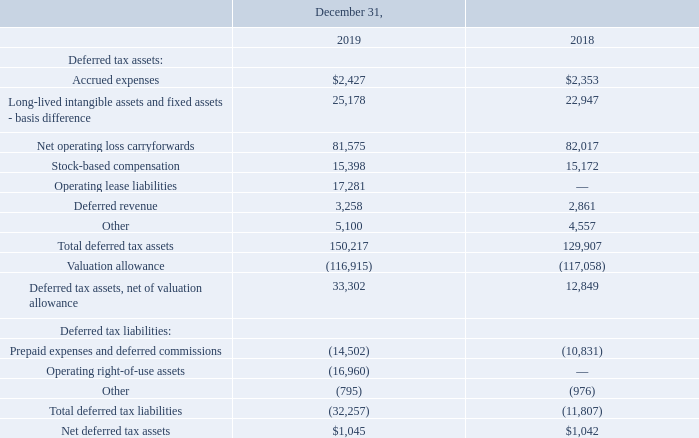Major components of the Company’s deferred tax assets (liabilities) are as follows (in thousands):
At December 31, 2019, the Company had federal, state, and foreign net operating losses of approximately $256.8 million, $275.5 million, and $89.7 million, respectively. The federal net operating loss carryforward will begin expiring in 2022, the state net operating loss carryforward will begin expiring in 2020, and the foreign net operating loss has an unlimited carryforward period. The Internal Revenue Code of 1986, as amended, imposes substantial restrictions on the utilization of net operating losses in the event of an “ownership change” of a corporation. Accordingly, a company’s ability to use net operating losses may be limited as prescribed under Internal Revenue Code Section 382 (“IRC Section 382”). Events which may cause limitations in the amount of the net operating losses that the Company may use in any one year include, but are not limited to, a cumulative ownership change of more than 50% over a three-year period. Due to the effects of historical equity issuances, the Company has determined that the future utilization of a portion of its net operating losses is limited annually pursuant to IRC Section 382. The Company has determined that none of its net operating losses will expire because of the annual limitation.
The Company has recorded a full valuation allowance against its otherwise recognizable US, UK, New Zealand, Hong Kong, and Brazil deferred income tax assets as of December 31, 2019. Management has determined, after evaluating all positive and negative historical and prospective evidence, that it is more likely than not that these assets will not be realized. The net (decrease) increase to the valuation allowance of $(0.1) million, $(1.5) million, and $6.8 million for the years ended December 31, 2019, 2018, and 2017, respectively, was primarily due to additional net operating losses generated by the Company.
Deferred income taxes have not been provided on the undistributed earnings of the Company’s foreign subsidiaries because the Company’s practice and intent is to permanently reinvest these earnings. The cumulative amount of such undistributed earnings was $5.3 million and $3.1 million at December 31, 2019 and December 31, 2018, respectively. Any future distribution of these non-US earnings may subject the Company to state income taxes, as adjusted for tax credits, and foreign withholding taxes that the Company estimates would be $0.1 million and $0.1 million at December 31, 2019 and 2018, respectively.
What was the company's federal net operating losses in 2019? $256.8 million. What was the company's state net operating losses in 2019? $275.5 million. What was the Deferred tax assets, net of valuation allowance in 2019?
Answer scale should be: thousand. 33,302. What is the percentage change in Stock-based compensation between 2018 and 2019?
Answer scale should be: percent. (15,398-15,172)/15,172
Answer: 1.49. What is the percentage change in Deferred revenue between 2018 and 2019?
Answer scale should be: percent. (3,258-2,861)/2,861
Answer: 13.88. What percentage of total deferred tax assets consist of accrued expenses in 2018?
Answer scale should be: percent. (2,353/129,907)
Answer: 1.81. 